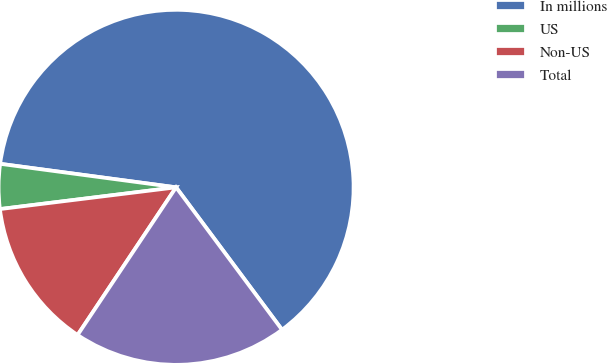Convert chart to OTSL. <chart><loc_0><loc_0><loc_500><loc_500><pie_chart><fcel>In millions<fcel>US<fcel>Non-US<fcel>Total<nl><fcel>62.7%<fcel>4.07%<fcel>13.68%<fcel>19.54%<nl></chart> 